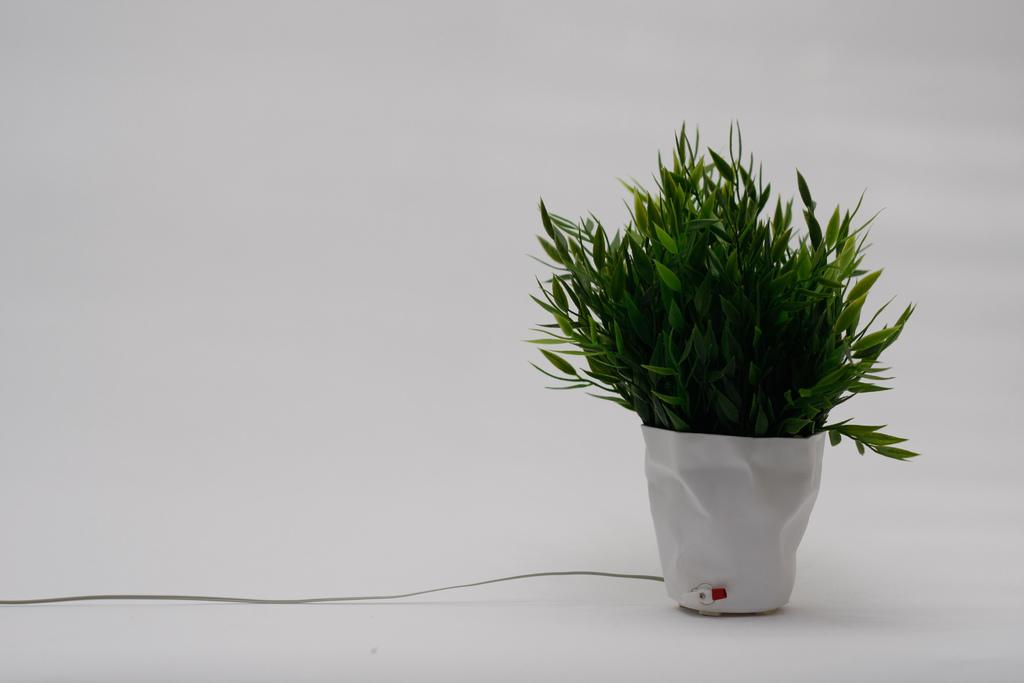What is in the pot that is visible in the image? There is a plant in a pot in the image. What additional feature can be seen on the pot? The pot has a wire. What color is the background of the image? The background of the image is white. How many friends does the plant have in the image? There are no friends present in the image, as it only features a plant in a pot. Who is the creator of the plant in the image? The image does not provide information about the creator of the plant; it only shows the plant in a pot with a wire. 